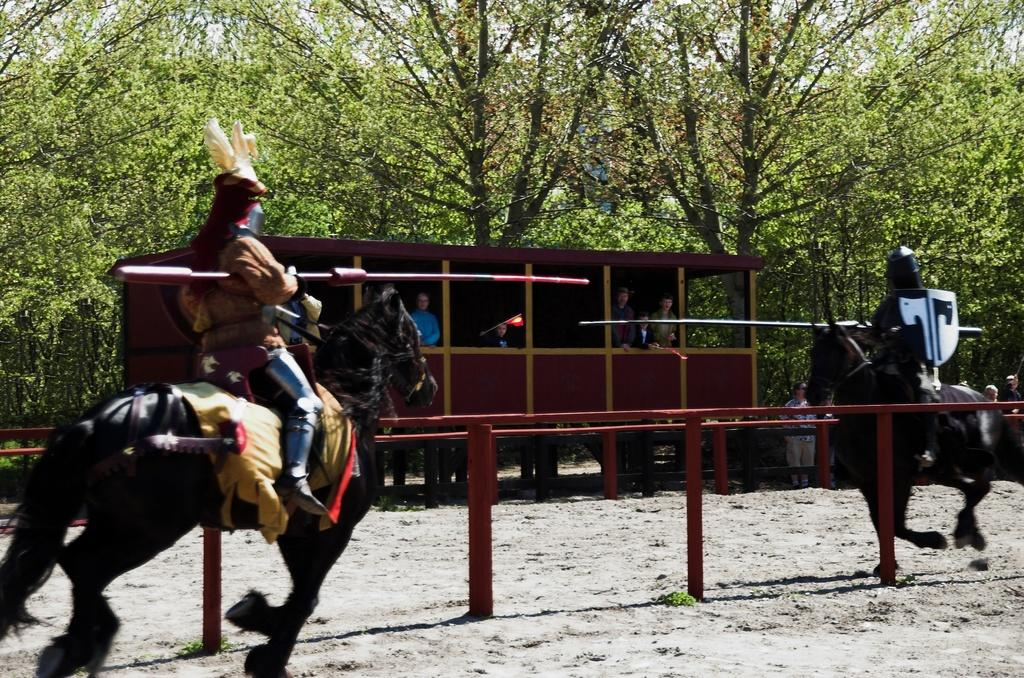What is the main subject of the image? The main subject of the image is a train. What else can be seen in the image besides the train? There is a railing, two horses, two men sitting on the horses, trees in the background, and the sky visible in the background. How many sticks are being used by the men in the image? There are no sticks present in the image; the men are sitting on horses. 